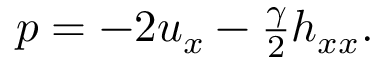<formula> <loc_0><loc_0><loc_500><loc_500>\begin{array} { r } { p = - 2 u _ { x } - \frac { \gamma } { 2 } h _ { x x } . } \end{array}</formula> 